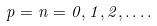Convert formula to latex. <formula><loc_0><loc_0><loc_500><loc_500>p = n = 0 , 1 , 2 , \dots .</formula> 